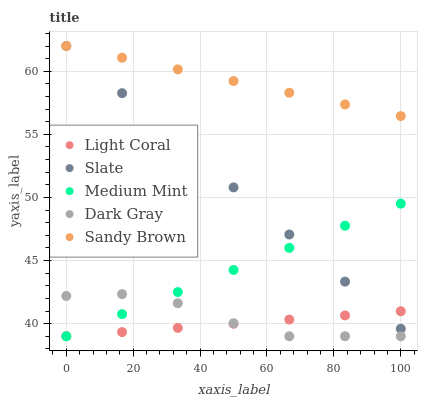Does Light Coral have the minimum area under the curve?
Answer yes or no. Yes. Does Sandy Brown have the maximum area under the curve?
Answer yes or no. Yes. Does Medium Mint have the minimum area under the curve?
Answer yes or no. No. Does Medium Mint have the maximum area under the curve?
Answer yes or no. No. Is Slate the smoothest?
Answer yes or no. Yes. Is Dark Gray the roughest?
Answer yes or no. Yes. Is Medium Mint the smoothest?
Answer yes or no. No. Is Medium Mint the roughest?
Answer yes or no. No. Does Light Coral have the lowest value?
Answer yes or no. Yes. Does Slate have the lowest value?
Answer yes or no. No. Does Sandy Brown have the highest value?
Answer yes or no. Yes. Does Medium Mint have the highest value?
Answer yes or no. No. Is Light Coral less than Sandy Brown?
Answer yes or no. Yes. Is Sandy Brown greater than Light Coral?
Answer yes or no. Yes. Does Dark Gray intersect Light Coral?
Answer yes or no. Yes. Is Dark Gray less than Light Coral?
Answer yes or no. No. Is Dark Gray greater than Light Coral?
Answer yes or no. No. Does Light Coral intersect Sandy Brown?
Answer yes or no. No. 